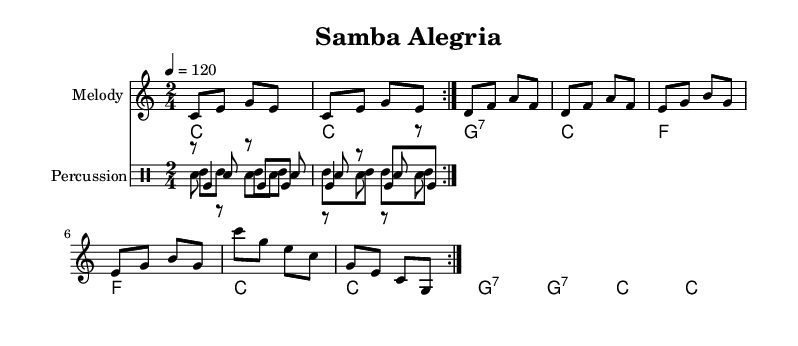What is the key signature of this music? The key signature is C major, which has no sharps or flats.
Answer: C major What is the time signature of the piece? The time signature is indicated at the beginning of the score as 2/4.
Answer: 2/4 What is the tempo marking for this piece? The tempo marking indicates that the speed is set at 120 beats per minute.
Answer: 120 How many times is the main melody repeated? The main melody is marked with "volta 2," meaning it is repeated twice.
Answer: 2 What percussion instrument is represented with the notation "sn"? The notation "sn" represents the snare drum, commonly used in samba rhythms.
Answer: snare drum Which chords are used in the last measure of the piece? The last measure of the piece consists of two C major chords being played consecutively.
Answer: C, C What is the rhythmic pattern for the surdo drum? The surdo drum rhythm consists of a pattern that alternates between a bass drum hit and a series of eighth notes.
Answer: bass, eighths 